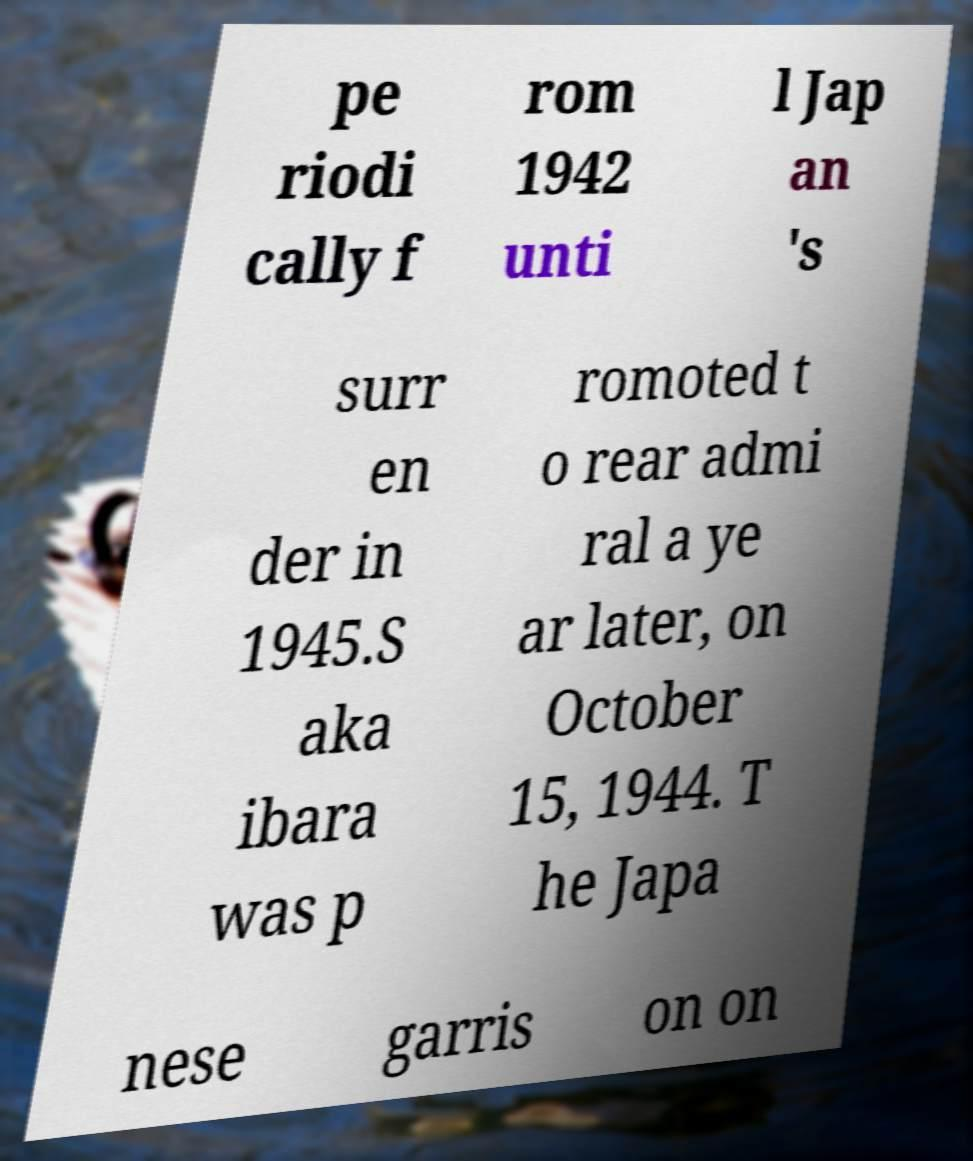For documentation purposes, I need the text within this image transcribed. Could you provide that? pe riodi cally f rom 1942 unti l Jap an 's surr en der in 1945.S aka ibara was p romoted t o rear admi ral a ye ar later, on October 15, 1944. T he Japa nese garris on on 